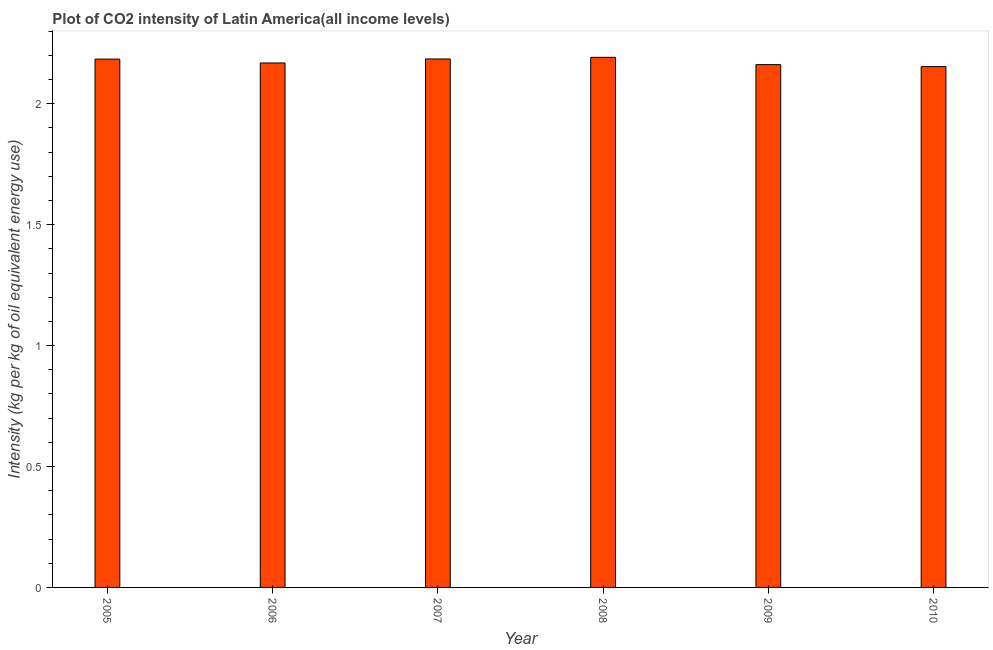What is the title of the graph?
Offer a terse response. Plot of CO2 intensity of Latin America(all income levels). What is the label or title of the Y-axis?
Provide a short and direct response. Intensity (kg per kg of oil equivalent energy use). What is the co2 intensity in 2008?
Provide a succinct answer. 2.19. Across all years, what is the maximum co2 intensity?
Keep it short and to the point. 2.19. Across all years, what is the minimum co2 intensity?
Offer a terse response. 2.15. In which year was the co2 intensity maximum?
Keep it short and to the point. 2008. In which year was the co2 intensity minimum?
Your answer should be very brief. 2010. What is the sum of the co2 intensity?
Ensure brevity in your answer.  13.05. What is the difference between the co2 intensity in 2008 and 2010?
Your answer should be very brief. 0.04. What is the average co2 intensity per year?
Offer a very short reply. 2.17. What is the median co2 intensity?
Make the answer very short. 2.18. In how many years, is the co2 intensity greater than 0.9 kg?
Offer a very short reply. 6. What is the difference between the highest and the second highest co2 intensity?
Ensure brevity in your answer.  0.01. What is the difference between the highest and the lowest co2 intensity?
Provide a short and direct response. 0.04. How many bars are there?
Provide a short and direct response. 6. What is the difference between two consecutive major ticks on the Y-axis?
Your answer should be very brief. 0.5. What is the Intensity (kg per kg of oil equivalent energy use) of 2005?
Provide a succinct answer. 2.18. What is the Intensity (kg per kg of oil equivalent energy use) in 2006?
Provide a succinct answer. 2.17. What is the Intensity (kg per kg of oil equivalent energy use) of 2007?
Offer a very short reply. 2.19. What is the Intensity (kg per kg of oil equivalent energy use) in 2008?
Ensure brevity in your answer.  2.19. What is the Intensity (kg per kg of oil equivalent energy use) of 2009?
Give a very brief answer. 2.16. What is the Intensity (kg per kg of oil equivalent energy use) in 2010?
Make the answer very short. 2.15. What is the difference between the Intensity (kg per kg of oil equivalent energy use) in 2005 and 2006?
Give a very brief answer. 0.02. What is the difference between the Intensity (kg per kg of oil equivalent energy use) in 2005 and 2007?
Give a very brief answer. -0. What is the difference between the Intensity (kg per kg of oil equivalent energy use) in 2005 and 2008?
Offer a very short reply. -0.01. What is the difference between the Intensity (kg per kg of oil equivalent energy use) in 2005 and 2009?
Provide a succinct answer. 0.02. What is the difference between the Intensity (kg per kg of oil equivalent energy use) in 2005 and 2010?
Provide a succinct answer. 0.03. What is the difference between the Intensity (kg per kg of oil equivalent energy use) in 2006 and 2007?
Offer a very short reply. -0.02. What is the difference between the Intensity (kg per kg of oil equivalent energy use) in 2006 and 2008?
Offer a terse response. -0.02. What is the difference between the Intensity (kg per kg of oil equivalent energy use) in 2006 and 2009?
Provide a succinct answer. 0.01. What is the difference between the Intensity (kg per kg of oil equivalent energy use) in 2006 and 2010?
Offer a very short reply. 0.02. What is the difference between the Intensity (kg per kg of oil equivalent energy use) in 2007 and 2008?
Your answer should be very brief. -0.01. What is the difference between the Intensity (kg per kg of oil equivalent energy use) in 2007 and 2009?
Keep it short and to the point. 0.02. What is the difference between the Intensity (kg per kg of oil equivalent energy use) in 2007 and 2010?
Keep it short and to the point. 0.03. What is the difference between the Intensity (kg per kg of oil equivalent energy use) in 2008 and 2009?
Your answer should be very brief. 0.03. What is the difference between the Intensity (kg per kg of oil equivalent energy use) in 2008 and 2010?
Your answer should be very brief. 0.04. What is the difference between the Intensity (kg per kg of oil equivalent energy use) in 2009 and 2010?
Provide a short and direct response. 0.01. What is the ratio of the Intensity (kg per kg of oil equivalent energy use) in 2005 to that in 2007?
Make the answer very short. 1. What is the ratio of the Intensity (kg per kg of oil equivalent energy use) in 2005 to that in 2009?
Your answer should be very brief. 1.01. What is the ratio of the Intensity (kg per kg of oil equivalent energy use) in 2005 to that in 2010?
Your response must be concise. 1.01. What is the ratio of the Intensity (kg per kg of oil equivalent energy use) in 2006 to that in 2007?
Provide a succinct answer. 0.99. What is the ratio of the Intensity (kg per kg of oil equivalent energy use) in 2007 to that in 2009?
Your answer should be very brief. 1.01. What is the ratio of the Intensity (kg per kg of oil equivalent energy use) in 2008 to that in 2009?
Provide a short and direct response. 1.01. What is the ratio of the Intensity (kg per kg of oil equivalent energy use) in 2009 to that in 2010?
Offer a terse response. 1. 